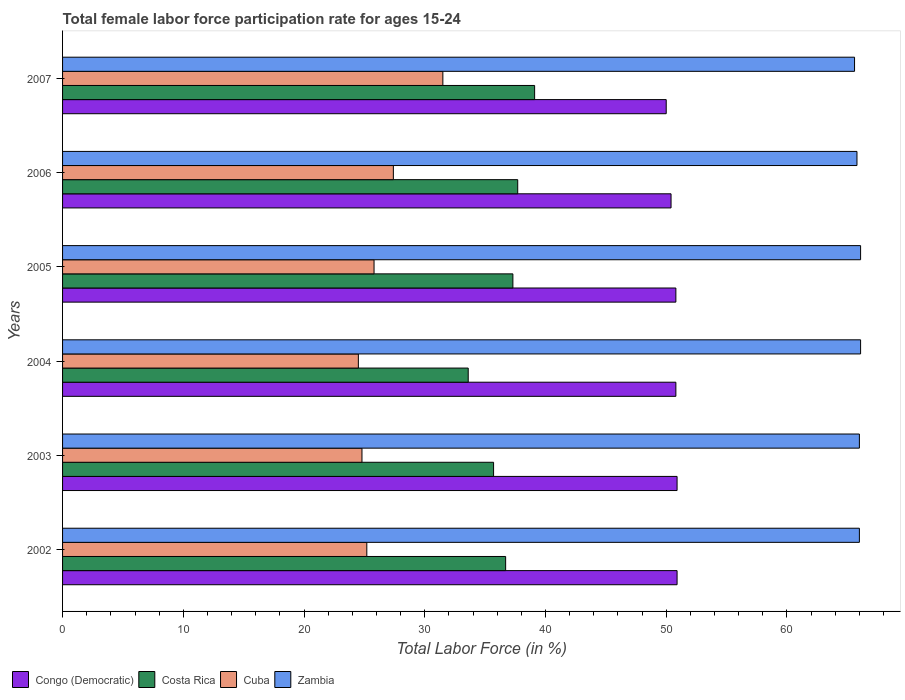How many different coloured bars are there?
Give a very brief answer. 4. How many groups of bars are there?
Your answer should be very brief. 6. How many bars are there on the 5th tick from the top?
Your response must be concise. 4. What is the label of the 1st group of bars from the top?
Provide a short and direct response. 2007. What is the female labor force participation rate in Zambia in 2003?
Make the answer very short. 66. Across all years, what is the maximum female labor force participation rate in Costa Rica?
Keep it short and to the point. 39.1. Across all years, what is the minimum female labor force participation rate in Zambia?
Give a very brief answer. 65.6. In which year was the female labor force participation rate in Congo (Democratic) minimum?
Make the answer very short. 2007. What is the total female labor force participation rate in Congo (Democratic) in the graph?
Provide a succinct answer. 303.8. What is the difference between the female labor force participation rate in Congo (Democratic) in 2005 and that in 2007?
Ensure brevity in your answer.  0.8. What is the difference between the female labor force participation rate in Zambia in 2004 and the female labor force participation rate in Cuba in 2002?
Your answer should be very brief. 40.9. What is the average female labor force participation rate in Congo (Democratic) per year?
Offer a terse response. 50.63. In the year 2005, what is the difference between the female labor force participation rate in Zambia and female labor force participation rate in Costa Rica?
Provide a succinct answer. 28.8. What is the ratio of the female labor force participation rate in Costa Rica in 2004 to that in 2005?
Offer a terse response. 0.9. Is the female labor force participation rate in Costa Rica in 2002 less than that in 2004?
Give a very brief answer. No. Is the difference between the female labor force participation rate in Zambia in 2005 and 2007 greater than the difference between the female labor force participation rate in Costa Rica in 2005 and 2007?
Keep it short and to the point. Yes. What is the difference between the highest and the second highest female labor force participation rate in Congo (Democratic)?
Provide a short and direct response. 0. What is the difference between the highest and the lowest female labor force participation rate in Cuba?
Offer a terse response. 7. In how many years, is the female labor force participation rate in Costa Rica greater than the average female labor force participation rate in Costa Rica taken over all years?
Give a very brief answer. 4. Is the sum of the female labor force participation rate in Cuba in 2004 and 2006 greater than the maximum female labor force participation rate in Costa Rica across all years?
Offer a very short reply. Yes. What does the 2nd bar from the top in 2006 represents?
Provide a short and direct response. Cuba. Is it the case that in every year, the sum of the female labor force participation rate in Costa Rica and female labor force participation rate in Cuba is greater than the female labor force participation rate in Zambia?
Offer a very short reply. No. How many bars are there?
Provide a succinct answer. 24. Are the values on the major ticks of X-axis written in scientific E-notation?
Offer a terse response. No. Does the graph contain any zero values?
Your answer should be very brief. No. Does the graph contain grids?
Your response must be concise. No. Where does the legend appear in the graph?
Provide a succinct answer. Bottom left. How many legend labels are there?
Provide a short and direct response. 4. What is the title of the graph?
Provide a short and direct response. Total female labor force participation rate for ages 15-24. Does "Fragile and conflict affected situations" appear as one of the legend labels in the graph?
Give a very brief answer. No. What is the label or title of the X-axis?
Make the answer very short. Total Labor Force (in %). What is the Total Labor Force (in %) in Congo (Democratic) in 2002?
Ensure brevity in your answer.  50.9. What is the Total Labor Force (in %) in Costa Rica in 2002?
Your answer should be compact. 36.7. What is the Total Labor Force (in %) in Cuba in 2002?
Your answer should be compact. 25.2. What is the Total Labor Force (in %) of Zambia in 2002?
Make the answer very short. 66. What is the Total Labor Force (in %) in Congo (Democratic) in 2003?
Keep it short and to the point. 50.9. What is the Total Labor Force (in %) in Costa Rica in 2003?
Offer a very short reply. 35.7. What is the Total Labor Force (in %) of Cuba in 2003?
Keep it short and to the point. 24.8. What is the Total Labor Force (in %) in Congo (Democratic) in 2004?
Ensure brevity in your answer.  50.8. What is the Total Labor Force (in %) of Costa Rica in 2004?
Offer a terse response. 33.6. What is the Total Labor Force (in %) in Cuba in 2004?
Provide a succinct answer. 24.5. What is the Total Labor Force (in %) in Zambia in 2004?
Your response must be concise. 66.1. What is the Total Labor Force (in %) in Congo (Democratic) in 2005?
Offer a very short reply. 50.8. What is the Total Labor Force (in %) of Costa Rica in 2005?
Give a very brief answer. 37.3. What is the Total Labor Force (in %) in Cuba in 2005?
Your answer should be compact. 25.8. What is the Total Labor Force (in %) in Zambia in 2005?
Ensure brevity in your answer.  66.1. What is the Total Labor Force (in %) in Congo (Democratic) in 2006?
Offer a terse response. 50.4. What is the Total Labor Force (in %) of Costa Rica in 2006?
Make the answer very short. 37.7. What is the Total Labor Force (in %) in Cuba in 2006?
Your answer should be very brief. 27.4. What is the Total Labor Force (in %) of Zambia in 2006?
Give a very brief answer. 65.8. What is the Total Labor Force (in %) in Costa Rica in 2007?
Your response must be concise. 39.1. What is the Total Labor Force (in %) of Cuba in 2007?
Offer a terse response. 31.5. What is the Total Labor Force (in %) of Zambia in 2007?
Give a very brief answer. 65.6. Across all years, what is the maximum Total Labor Force (in %) in Congo (Democratic)?
Keep it short and to the point. 50.9. Across all years, what is the maximum Total Labor Force (in %) of Costa Rica?
Provide a succinct answer. 39.1. Across all years, what is the maximum Total Labor Force (in %) of Cuba?
Your answer should be compact. 31.5. Across all years, what is the maximum Total Labor Force (in %) of Zambia?
Offer a terse response. 66.1. Across all years, what is the minimum Total Labor Force (in %) of Congo (Democratic)?
Keep it short and to the point. 50. Across all years, what is the minimum Total Labor Force (in %) in Costa Rica?
Give a very brief answer. 33.6. Across all years, what is the minimum Total Labor Force (in %) in Zambia?
Your answer should be compact. 65.6. What is the total Total Labor Force (in %) in Congo (Democratic) in the graph?
Offer a terse response. 303.8. What is the total Total Labor Force (in %) in Costa Rica in the graph?
Offer a terse response. 220.1. What is the total Total Labor Force (in %) of Cuba in the graph?
Keep it short and to the point. 159.2. What is the total Total Labor Force (in %) of Zambia in the graph?
Offer a terse response. 395.6. What is the difference between the Total Labor Force (in %) of Costa Rica in 2002 and that in 2003?
Your answer should be very brief. 1. What is the difference between the Total Labor Force (in %) in Zambia in 2002 and that in 2003?
Offer a very short reply. 0. What is the difference between the Total Labor Force (in %) in Costa Rica in 2002 and that in 2004?
Make the answer very short. 3.1. What is the difference between the Total Labor Force (in %) of Cuba in 2002 and that in 2004?
Provide a succinct answer. 0.7. What is the difference between the Total Labor Force (in %) in Congo (Democratic) in 2002 and that in 2005?
Give a very brief answer. 0.1. What is the difference between the Total Labor Force (in %) in Costa Rica in 2002 and that in 2005?
Ensure brevity in your answer.  -0.6. What is the difference between the Total Labor Force (in %) of Cuba in 2002 and that in 2005?
Make the answer very short. -0.6. What is the difference between the Total Labor Force (in %) of Cuba in 2002 and that in 2006?
Offer a terse response. -2.2. What is the difference between the Total Labor Force (in %) in Cuba in 2002 and that in 2007?
Ensure brevity in your answer.  -6.3. What is the difference between the Total Labor Force (in %) of Zambia in 2002 and that in 2007?
Provide a succinct answer. 0.4. What is the difference between the Total Labor Force (in %) in Congo (Democratic) in 2003 and that in 2004?
Offer a very short reply. 0.1. What is the difference between the Total Labor Force (in %) in Congo (Democratic) in 2003 and that in 2005?
Provide a short and direct response. 0.1. What is the difference between the Total Labor Force (in %) in Costa Rica in 2003 and that in 2005?
Provide a short and direct response. -1.6. What is the difference between the Total Labor Force (in %) in Zambia in 2003 and that in 2005?
Your answer should be compact. -0.1. What is the difference between the Total Labor Force (in %) of Congo (Democratic) in 2003 and that in 2006?
Give a very brief answer. 0.5. What is the difference between the Total Labor Force (in %) in Costa Rica in 2003 and that in 2006?
Your answer should be compact. -2. What is the difference between the Total Labor Force (in %) in Cuba in 2003 and that in 2006?
Make the answer very short. -2.6. What is the difference between the Total Labor Force (in %) in Zambia in 2003 and that in 2006?
Offer a terse response. 0.2. What is the difference between the Total Labor Force (in %) of Cuba in 2003 and that in 2007?
Keep it short and to the point. -6.7. What is the difference between the Total Labor Force (in %) in Zambia in 2003 and that in 2007?
Give a very brief answer. 0.4. What is the difference between the Total Labor Force (in %) of Congo (Democratic) in 2004 and that in 2005?
Give a very brief answer. 0. What is the difference between the Total Labor Force (in %) of Costa Rica in 2004 and that in 2005?
Offer a very short reply. -3.7. What is the difference between the Total Labor Force (in %) in Costa Rica in 2004 and that in 2006?
Give a very brief answer. -4.1. What is the difference between the Total Labor Force (in %) in Cuba in 2004 and that in 2006?
Make the answer very short. -2.9. What is the difference between the Total Labor Force (in %) in Zambia in 2004 and that in 2006?
Provide a succinct answer. 0.3. What is the difference between the Total Labor Force (in %) of Cuba in 2004 and that in 2007?
Offer a very short reply. -7. What is the difference between the Total Labor Force (in %) in Zambia in 2004 and that in 2007?
Keep it short and to the point. 0.5. What is the difference between the Total Labor Force (in %) of Costa Rica in 2005 and that in 2006?
Offer a very short reply. -0.4. What is the difference between the Total Labor Force (in %) of Zambia in 2005 and that in 2006?
Give a very brief answer. 0.3. What is the difference between the Total Labor Force (in %) of Costa Rica in 2006 and that in 2007?
Provide a short and direct response. -1.4. What is the difference between the Total Labor Force (in %) of Cuba in 2006 and that in 2007?
Your response must be concise. -4.1. What is the difference between the Total Labor Force (in %) of Congo (Democratic) in 2002 and the Total Labor Force (in %) of Costa Rica in 2003?
Your answer should be very brief. 15.2. What is the difference between the Total Labor Force (in %) of Congo (Democratic) in 2002 and the Total Labor Force (in %) of Cuba in 2003?
Offer a very short reply. 26.1. What is the difference between the Total Labor Force (in %) in Congo (Democratic) in 2002 and the Total Labor Force (in %) in Zambia in 2003?
Your answer should be compact. -15.1. What is the difference between the Total Labor Force (in %) of Costa Rica in 2002 and the Total Labor Force (in %) of Zambia in 2003?
Offer a very short reply. -29.3. What is the difference between the Total Labor Force (in %) in Cuba in 2002 and the Total Labor Force (in %) in Zambia in 2003?
Your answer should be very brief. -40.8. What is the difference between the Total Labor Force (in %) in Congo (Democratic) in 2002 and the Total Labor Force (in %) in Costa Rica in 2004?
Keep it short and to the point. 17.3. What is the difference between the Total Labor Force (in %) in Congo (Democratic) in 2002 and the Total Labor Force (in %) in Cuba in 2004?
Offer a terse response. 26.4. What is the difference between the Total Labor Force (in %) of Congo (Democratic) in 2002 and the Total Labor Force (in %) of Zambia in 2004?
Your response must be concise. -15.2. What is the difference between the Total Labor Force (in %) in Costa Rica in 2002 and the Total Labor Force (in %) in Cuba in 2004?
Your answer should be very brief. 12.2. What is the difference between the Total Labor Force (in %) in Costa Rica in 2002 and the Total Labor Force (in %) in Zambia in 2004?
Provide a short and direct response. -29.4. What is the difference between the Total Labor Force (in %) of Cuba in 2002 and the Total Labor Force (in %) of Zambia in 2004?
Make the answer very short. -40.9. What is the difference between the Total Labor Force (in %) of Congo (Democratic) in 2002 and the Total Labor Force (in %) of Costa Rica in 2005?
Offer a very short reply. 13.6. What is the difference between the Total Labor Force (in %) of Congo (Democratic) in 2002 and the Total Labor Force (in %) of Cuba in 2005?
Offer a very short reply. 25.1. What is the difference between the Total Labor Force (in %) in Congo (Democratic) in 2002 and the Total Labor Force (in %) in Zambia in 2005?
Provide a short and direct response. -15.2. What is the difference between the Total Labor Force (in %) in Costa Rica in 2002 and the Total Labor Force (in %) in Zambia in 2005?
Provide a short and direct response. -29.4. What is the difference between the Total Labor Force (in %) of Cuba in 2002 and the Total Labor Force (in %) of Zambia in 2005?
Give a very brief answer. -40.9. What is the difference between the Total Labor Force (in %) of Congo (Democratic) in 2002 and the Total Labor Force (in %) of Costa Rica in 2006?
Provide a short and direct response. 13.2. What is the difference between the Total Labor Force (in %) in Congo (Democratic) in 2002 and the Total Labor Force (in %) in Cuba in 2006?
Keep it short and to the point. 23.5. What is the difference between the Total Labor Force (in %) in Congo (Democratic) in 2002 and the Total Labor Force (in %) in Zambia in 2006?
Your response must be concise. -14.9. What is the difference between the Total Labor Force (in %) of Costa Rica in 2002 and the Total Labor Force (in %) of Cuba in 2006?
Make the answer very short. 9.3. What is the difference between the Total Labor Force (in %) in Costa Rica in 2002 and the Total Labor Force (in %) in Zambia in 2006?
Ensure brevity in your answer.  -29.1. What is the difference between the Total Labor Force (in %) of Cuba in 2002 and the Total Labor Force (in %) of Zambia in 2006?
Your answer should be very brief. -40.6. What is the difference between the Total Labor Force (in %) of Congo (Democratic) in 2002 and the Total Labor Force (in %) of Costa Rica in 2007?
Your answer should be very brief. 11.8. What is the difference between the Total Labor Force (in %) in Congo (Democratic) in 2002 and the Total Labor Force (in %) in Zambia in 2007?
Offer a terse response. -14.7. What is the difference between the Total Labor Force (in %) in Costa Rica in 2002 and the Total Labor Force (in %) in Zambia in 2007?
Keep it short and to the point. -28.9. What is the difference between the Total Labor Force (in %) of Cuba in 2002 and the Total Labor Force (in %) of Zambia in 2007?
Make the answer very short. -40.4. What is the difference between the Total Labor Force (in %) of Congo (Democratic) in 2003 and the Total Labor Force (in %) of Costa Rica in 2004?
Offer a terse response. 17.3. What is the difference between the Total Labor Force (in %) in Congo (Democratic) in 2003 and the Total Labor Force (in %) in Cuba in 2004?
Make the answer very short. 26.4. What is the difference between the Total Labor Force (in %) in Congo (Democratic) in 2003 and the Total Labor Force (in %) in Zambia in 2004?
Your response must be concise. -15.2. What is the difference between the Total Labor Force (in %) in Costa Rica in 2003 and the Total Labor Force (in %) in Zambia in 2004?
Offer a terse response. -30.4. What is the difference between the Total Labor Force (in %) of Cuba in 2003 and the Total Labor Force (in %) of Zambia in 2004?
Provide a succinct answer. -41.3. What is the difference between the Total Labor Force (in %) of Congo (Democratic) in 2003 and the Total Labor Force (in %) of Costa Rica in 2005?
Give a very brief answer. 13.6. What is the difference between the Total Labor Force (in %) in Congo (Democratic) in 2003 and the Total Labor Force (in %) in Cuba in 2005?
Ensure brevity in your answer.  25.1. What is the difference between the Total Labor Force (in %) in Congo (Democratic) in 2003 and the Total Labor Force (in %) in Zambia in 2005?
Offer a very short reply. -15.2. What is the difference between the Total Labor Force (in %) of Costa Rica in 2003 and the Total Labor Force (in %) of Zambia in 2005?
Keep it short and to the point. -30.4. What is the difference between the Total Labor Force (in %) in Cuba in 2003 and the Total Labor Force (in %) in Zambia in 2005?
Ensure brevity in your answer.  -41.3. What is the difference between the Total Labor Force (in %) in Congo (Democratic) in 2003 and the Total Labor Force (in %) in Costa Rica in 2006?
Make the answer very short. 13.2. What is the difference between the Total Labor Force (in %) in Congo (Democratic) in 2003 and the Total Labor Force (in %) in Zambia in 2006?
Give a very brief answer. -14.9. What is the difference between the Total Labor Force (in %) of Costa Rica in 2003 and the Total Labor Force (in %) of Zambia in 2006?
Your answer should be compact. -30.1. What is the difference between the Total Labor Force (in %) in Cuba in 2003 and the Total Labor Force (in %) in Zambia in 2006?
Offer a very short reply. -41. What is the difference between the Total Labor Force (in %) of Congo (Democratic) in 2003 and the Total Labor Force (in %) of Zambia in 2007?
Keep it short and to the point. -14.7. What is the difference between the Total Labor Force (in %) of Costa Rica in 2003 and the Total Labor Force (in %) of Cuba in 2007?
Provide a succinct answer. 4.2. What is the difference between the Total Labor Force (in %) in Costa Rica in 2003 and the Total Labor Force (in %) in Zambia in 2007?
Provide a succinct answer. -29.9. What is the difference between the Total Labor Force (in %) of Cuba in 2003 and the Total Labor Force (in %) of Zambia in 2007?
Offer a very short reply. -40.8. What is the difference between the Total Labor Force (in %) in Congo (Democratic) in 2004 and the Total Labor Force (in %) in Costa Rica in 2005?
Your answer should be compact. 13.5. What is the difference between the Total Labor Force (in %) in Congo (Democratic) in 2004 and the Total Labor Force (in %) in Cuba in 2005?
Your answer should be very brief. 25. What is the difference between the Total Labor Force (in %) of Congo (Democratic) in 2004 and the Total Labor Force (in %) of Zambia in 2005?
Ensure brevity in your answer.  -15.3. What is the difference between the Total Labor Force (in %) in Costa Rica in 2004 and the Total Labor Force (in %) in Cuba in 2005?
Offer a very short reply. 7.8. What is the difference between the Total Labor Force (in %) in Costa Rica in 2004 and the Total Labor Force (in %) in Zambia in 2005?
Keep it short and to the point. -32.5. What is the difference between the Total Labor Force (in %) in Cuba in 2004 and the Total Labor Force (in %) in Zambia in 2005?
Your answer should be very brief. -41.6. What is the difference between the Total Labor Force (in %) of Congo (Democratic) in 2004 and the Total Labor Force (in %) of Costa Rica in 2006?
Your answer should be very brief. 13.1. What is the difference between the Total Labor Force (in %) of Congo (Democratic) in 2004 and the Total Labor Force (in %) of Cuba in 2006?
Ensure brevity in your answer.  23.4. What is the difference between the Total Labor Force (in %) in Costa Rica in 2004 and the Total Labor Force (in %) in Cuba in 2006?
Ensure brevity in your answer.  6.2. What is the difference between the Total Labor Force (in %) in Costa Rica in 2004 and the Total Labor Force (in %) in Zambia in 2006?
Offer a very short reply. -32.2. What is the difference between the Total Labor Force (in %) in Cuba in 2004 and the Total Labor Force (in %) in Zambia in 2006?
Your answer should be compact. -41.3. What is the difference between the Total Labor Force (in %) of Congo (Democratic) in 2004 and the Total Labor Force (in %) of Costa Rica in 2007?
Your answer should be very brief. 11.7. What is the difference between the Total Labor Force (in %) of Congo (Democratic) in 2004 and the Total Labor Force (in %) of Cuba in 2007?
Make the answer very short. 19.3. What is the difference between the Total Labor Force (in %) in Congo (Democratic) in 2004 and the Total Labor Force (in %) in Zambia in 2007?
Give a very brief answer. -14.8. What is the difference between the Total Labor Force (in %) in Costa Rica in 2004 and the Total Labor Force (in %) in Zambia in 2007?
Offer a very short reply. -32. What is the difference between the Total Labor Force (in %) in Cuba in 2004 and the Total Labor Force (in %) in Zambia in 2007?
Make the answer very short. -41.1. What is the difference between the Total Labor Force (in %) in Congo (Democratic) in 2005 and the Total Labor Force (in %) in Costa Rica in 2006?
Provide a short and direct response. 13.1. What is the difference between the Total Labor Force (in %) of Congo (Democratic) in 2005 and the Total Labor Force (in %) of Cuba in 2006?
Keep it short and to the point. 23.4. What is the difference between the Total Labor Force (in %) in Costa Rica in 2005 and the Total Labor Force (in %) in Zambia in 2006?
Give a very brief answer. -28.5. What is the difference between the Total Labor Force (in %) in Cuba in 2005 and the Total Labor Force (in %) in Zambia in 2006?
Provide a succinct answer. -40. What is the difference between the Total Labor Force (in %) of Congo (Democratic) in 2005 and the Total Labor Force (in %) of Cuba in 2007?
Your answer should be compact. 19.3. What is the difference between the Total Labor Force (in %) in Congo (Democratic) in 2005 and the Total Labor Force (in %) in Zambia in 2007?
Offer a very short reply. -14.8. What is the difference between the Total Labor Force (in %) in Costa Rica in 2005 and the Total Labor Force (in %) in Zambia in 2007?
Provide a succinct answer. -28.3. What is the difference between the Total Labor Force (in %) of Cuba in 2005 and the Total Labor Force (in %) of Zambia in 2007?
Your answer should be compact. -39.8. What is the difference between the Total Labor Force (in %) of Congo (Democratic) in 2006 and the Total Labor Force (in %) of Cuba in 2007?
Offer a terse response. 18.9. What is the difference between the Total Labor Force (in %) in Congo (Democratic) in 2006 and the Total Labor Force (in %) in Zambia in 2007?
Your answer should be compact. -15.2. What is the difference between the Total Labor Force (in %) in Costa Rica in 2006 and the Total Labor Force (in %) in Cuba in 2007?
Your response must be concise. 6.2. What is the difference between the Total Labor Force (in %) of Costa Rica in 2006 and the Total Labor Force (in %) of Zambia in 2007?
Your answer should be very brief. -27.9. What is the difference between the Total Labor Force (in %) in Cuba in 2006 and the Total Labor Force (in %) in Zambia in 2007?
Offer a very short reply. -38.2. What is the average Total Labor Force (in %) of Congo (Democratic) per year?
Make the answer very short. 50.63. What is the average Total Labor Force (in %) in Costa Rica per year?
Give a very brief answer. 36.68. What is the average Total Labor Force (in %) in Cuba per year?
Keep it short and to the point. 26.53. What is the average Total Labor Force (in %) in Zambia per year?
Your answer should be very brief. 65.93. In the year 2002, what is the difference between the Total Labor Force (in %) of Congo (Democratic) and Total Labor Force (in %) of Costa Rica?
Offer a terse response. 14.2. In the year 2002, what is the difference between the Total Labor Force (in %) of Congo (Democratic) and Total Labor Force (in %) of Cuba?
Provide a succinct answer. 25.7. In the year 2002, what is the difference between the Total Labor Force (in %) in Congo (Democratic) and Total Labor Force (in %) in Zambia?
Provide a short and direct response. -15.1. In the year 2002, what is the difference between the Total Labor Force (in %) in Costa Rica and Total Labor Force (in %) in Zambia?
Offer a terse response. -29.3. In the year 2002, what is the difference between the Total Labor Force (in %) in Cuba and Total Labor Force (in %) in Zambia?
Your answer should be compact. -40.8. In the year 2003, what is the difference between the Total Labor Force (in %) in Congo (Democratic) and Total Labor Force (in %) in Cuba?
Provide a succinct answer. 26.1. In the year 2003, what is the difference between the Total Labor Force (in %) of Congo (Democratic) and Total Labor Force (in %) of Zambia?
Give a very brief answer. -15.1. In the year 2003, what is the difference between the Total Labor Force (in %) in Costa Rica and Total Labor Force (in %) in Cuba?
Your response must be concise. 10.9. In the year 2003, what is the difference between the Total Labor Force (in %) in Costa Rica and Total Labor Force (in %) in Zambia?
Provide a short and direct response. -30.3. In the year 2003, what is the difference between the Total Labor Force (in %) in Cuba and Total Labor Force (in %) in Zambia?
Ensure brevity in your answer.  -41.2. In the year 2004, what is the difference between the Total Labor Force (in %) of Congo (Democratic) and Total Labor Force (in %) of Costa Rica?
Your answer should be very brief. 17.2. In the year 2004, what is the difference between the Total Labor Force (in %) in Congo (Democratic) and Total Labor Force (in %) in Cuba?
Keep it short and to the point. 26.3. In the year 2004, what is the difference between the Total Labor Force (in %) of Congo (Democratic) and Total Labor Force (in %) of Zambia?
Keep it short and to the point. -15.3. In the year 2004, what is the difference between the Total Labor Force (in %) in Costa Rica and Total Labor Force (in %) in Zambia?
Offer a very short reply. -32.5. In the year 2004, what is the difference between the Total Labor Force (in %) of Cuba and Total Labor Force (in %) of Zambia?
Make the answer very short. -41.6. In the year 2005, what is the difference between the Total Labor Force (in %) in Congo (Democratic) and Total Labor Force (in %) in Cuba?
Make the answer very short. 25. In the year 2005, what is the difference between the Total Labor Force (in %) in Congo (Democratic) and Total Labor Force (in %) in Zambia?
Offer a terse response. -15.3. In the year 2005, what is the difference between the Total Labor Force (in %) in Costa Rica and Total Labor Force (in %) in Cuba?
Provide a short and direct response. 11.5. In the year 2005, what is the difference between the Total Labor Force (in %) in Costa Rica and Total Labor Force (in %) in Zambia?
Offer a terse response. -28.8. In the year 2005, what is the difference between the Total Labor Force (in %) in Cuba and Total Labor Force (in %) in Zambia?
Offer a terse response. -40.3. In the year 2006, what is the difference between the Total Labor Force (in %) of Congo (Democratic) and Total Labor Force (in %) of Costa Rica?
Your answer should be compact. 12.7. In the year 2006, what is the difference between the Total Labor Force (in %) of Congo (Democratic) and Total Labor Force (in %) of Cuba?
Offer a terse response. 23. In the year 2006, what is the difference between the Total Labor Force (in %) of Congo (Democratic) and Total Labor Force (in %) of Zambia?
Provide a succinct answer. -15.4. In the year 2006, what is the difference between the Total Labor Force (in %) of Costa Rica and Total Labor Force (in %) of Zambia?
Keep it short and to the point. -28.1. In the year 2006, what is the difference between the Total Labor Force (in %) in Cuba and Total Labor Force (in %) in Zambia?
Make the answer very short. -38.4. In the year 2007, what is the difference between the Total Labor Force (in %) in Congo (Democratic) and Total Labor Force (in %) in Zambia?
Your answer should be very brief. -15.6. In the year 2007, what is the difference between the Total Labor Force (in %) in Costa Rica and Total Labor Force (in %) in Cuba?
Give a very brief answer. 7.6. In the year 2007, what is the difference between the Total Labor Force (in %) of Costa Rica and Total Labor Force (in %) of Zambia?
Provide a short and direct response. -26.5. In the year 2007, what is the difference between the Total Labor Force (in %) of Cuba and Total Labor Force (in %) of Zambia?
Your answer should be very brief. -34.1. What is the ratio of the Total Labor Force (in %) of Congo (Democratic) in 2002 to that in 2003?
Make the answer very short. 1. What is the ratio of the Total Labor Force (in %) in Costa Rica in 2002 to that in 2003?
Your answer should be very brief. 1.03. What is the ratio of the Total Labor Force (in %) in Cuba in 2002 to that in 2003?
Ensure brevity in your answer.  1.02. What is the ratio of the Total Labor Force (in %) of Costa Rica in 2002 to that in 2004?
Offer a very short reply. 1.09. What is the ratio of the Total Labor Force (in %) of Cuba in 2002 to that in 2004?
Your answer should be compact. 1.03. What is the ratio of the Total Labor Force (in %) of Zambia in 2002 to that in 2004?
Offer a terse response. 1. What is the ratio of the Total Labor Force (in %) in Congo (Democratic) in 2002 to that in 2005?
Make the answer very short. 1. What is the ratio of the Total Labor Force (in %) of Costa Rica in 2002 to that in 2005?
Your response must be concise. 0.98. What is the ratio of the Total Labor Force (in %) of Cuba in 2002 to that in 2005?
Provide a short and direct response. 0.98. What is the ratio of the Total Labor Force (in %) in Congo (Democratic) in 2002 to that in 2006?
Your answer should be compact. 1.01. What is the ratio of the Total Labor Force (in %) in Costa Rica in 2002 to that in 2006?
Your answer should be compact. 0.97. What is the ratio of the Total Labor Force (in %) of Cuba in 2002 to that in 2006?
Ensure brevity in your answer.  0.92. What is the ratio of the Total Labor Force (in %) of Zambia in 2002 to that in 2006?
Your answer should be compact. 1. What is the ratio of the Total Labor Force (in %) of Congo (Democratic) in 2002 to that in 2007?
Give a very brief answer. 1.02. What is the ratio of the Total Labor Force (in %) of Costa Rica in 2002 to that in 2007?
Your response must be concise. 0.94. What is the ratio of the Total Labor Force (in %) of Congo (Democratic) in 2003 to that in 2004?
Ensure brevity in your answer.  1. What is the ratio of the Total Labor Force (in %) in Cuba in 2003 to that in 2004?
Provide a succinct answer. 1.01. What is the ratio of the Total Labor Force (in %) in Congo (Democratic) in 2003 to that in 2005?
Provide a short and direct response. 1. What is the ratio of the Total Labor Force (in %) of Costa Rica in 2003 to that in 2005?
Provide a short and direct response. 0.96. What is the ratio of the Total Labor Force (in %) of Cuba in 2003 to that in 2005?
Offer a terse response. 0.96. What is the ratio of the Total Labor Force (in %) of Congo (Democratic) in 2003 to that in 2006?
Your answer should be compact. 1.01. What is the ratio of the Total Labor Force (in %) of Costa Rica in 2003 to that in 2006?
Make the answer very short. 0.95. What is the ratio of the Total Labor Force (in %) of Cuba in 2003 to that in 2006?
Offer a terse response. 0.91. What is the ratio of the Total Labor Force (in %) of Congo (Democratic) in 2003 to that in 2007?
Offer a terse response. 1.02. What is the ratio of the Total Labor Force (in %) in Costa Rica in 2003 to that in 2007?
Ensure brevity in your answer.  0.91. What is the ratio of the Total Labor Force (in %) of Cuba in 2003 to that in 2007?
Provide a succinct answer. 0.79. What is the ratio of the Total Labor Force (in %) in Zambia in 2003 to that in 2007?
Keep it short and to the point. 1.01. What is the ratio of the Total Labor Force (in %) in Costa Rica in 2004 to that in 2005?
Give a very brief answer. 0.9. What is the ratio of the Total Labor Force (in %) in Cuba in 2004 to that in 2005?
Offer a very short reply. 0.95. What is the ratio of the Total Labor Force (in %) in Congo (Democratic) in 2004 to that in 2006?
Provide a succinct answer. 1.01. What is the ratio of the Total Labor Force (in %) of Costa Rica in 2004 to that in 2006?
Ensure brevity in your answer.  0.89. What is the ratio of the Total Labor Force (in %) of Cuba in 2004 to that in 2006?
Your response must be concise. 0.89. What is the ratio of the Total Labor Force (in %) in Zambia in 2004 to that in 2006?
Provide a short and direct response. 1. What is the ratio of the Total Labor Force (in %) of Congo (Democratic) in 2004 to that in 2007?
Offer a terse response. 1.02. What is the ratio of the Total Labor Force (in %) in Costa Rica in 2004 to that in 2007?
Make the answer very short. 0.86. What is the ratio of the Total Labor Force (in %) of Zambia in 2004 to that in 2007?
Your response must be concise. 1.01. What is the ratio of the Total Labor Force (in %) in Congo (Democratic) in 2005 to that in 2006?
Your answer should be very brief. 1.01. What is the ratio of the Total Labor Force (in %) of Cuba in 2005 to that in 2006?
Your answer should be compact. 0.94. What is the ratio of the Total Labor Force (in %) in Congo (Democratic) in 2005 to that in 2007?
Give a very brief answer. 1.02. What is the ratio of the Total Labor Force (in %) of Costa Rica in 2005 to that in 2007?
Give a very brief answer. 0.95. What is the ratio of the Total Labor Force (in %) of Cuba in 2005 to that in 2007?
Offer a very short reply. 0.82. What is the ratio of the Total Labor Force (in %) in Zambia in 2005 to that in 2007?
Offer a very short reply. 1.01. What is the ratio of the Total Labor Force (in %) of Costa Rica in 2006 to that in 2007?
Ensure brevity in your answer.  0.96. What is the ratio of the Total Labor Force (in %) in Cuba in 2006 to that in 2007?
Ensure brevity in your answer.  0.87. What is the difference between the highest and the second highest Total Labor Force (in %) of Congo (Democratic)?
Give a very brief answer. 0. What is the difference between the highest and the second highest Total Labor Force (in %) of Costa Rica?
Ensure brevity in your answer.  1.4. What is the difference between the highest and the second highest Total Labor Force (in %) of Cuba?
Keep it short and to the point. 4.1. What is the difference between the highest and the lowest Total Labor Force (in %) of Costa Rica?
Ensure brevity in your answer.  5.5. 